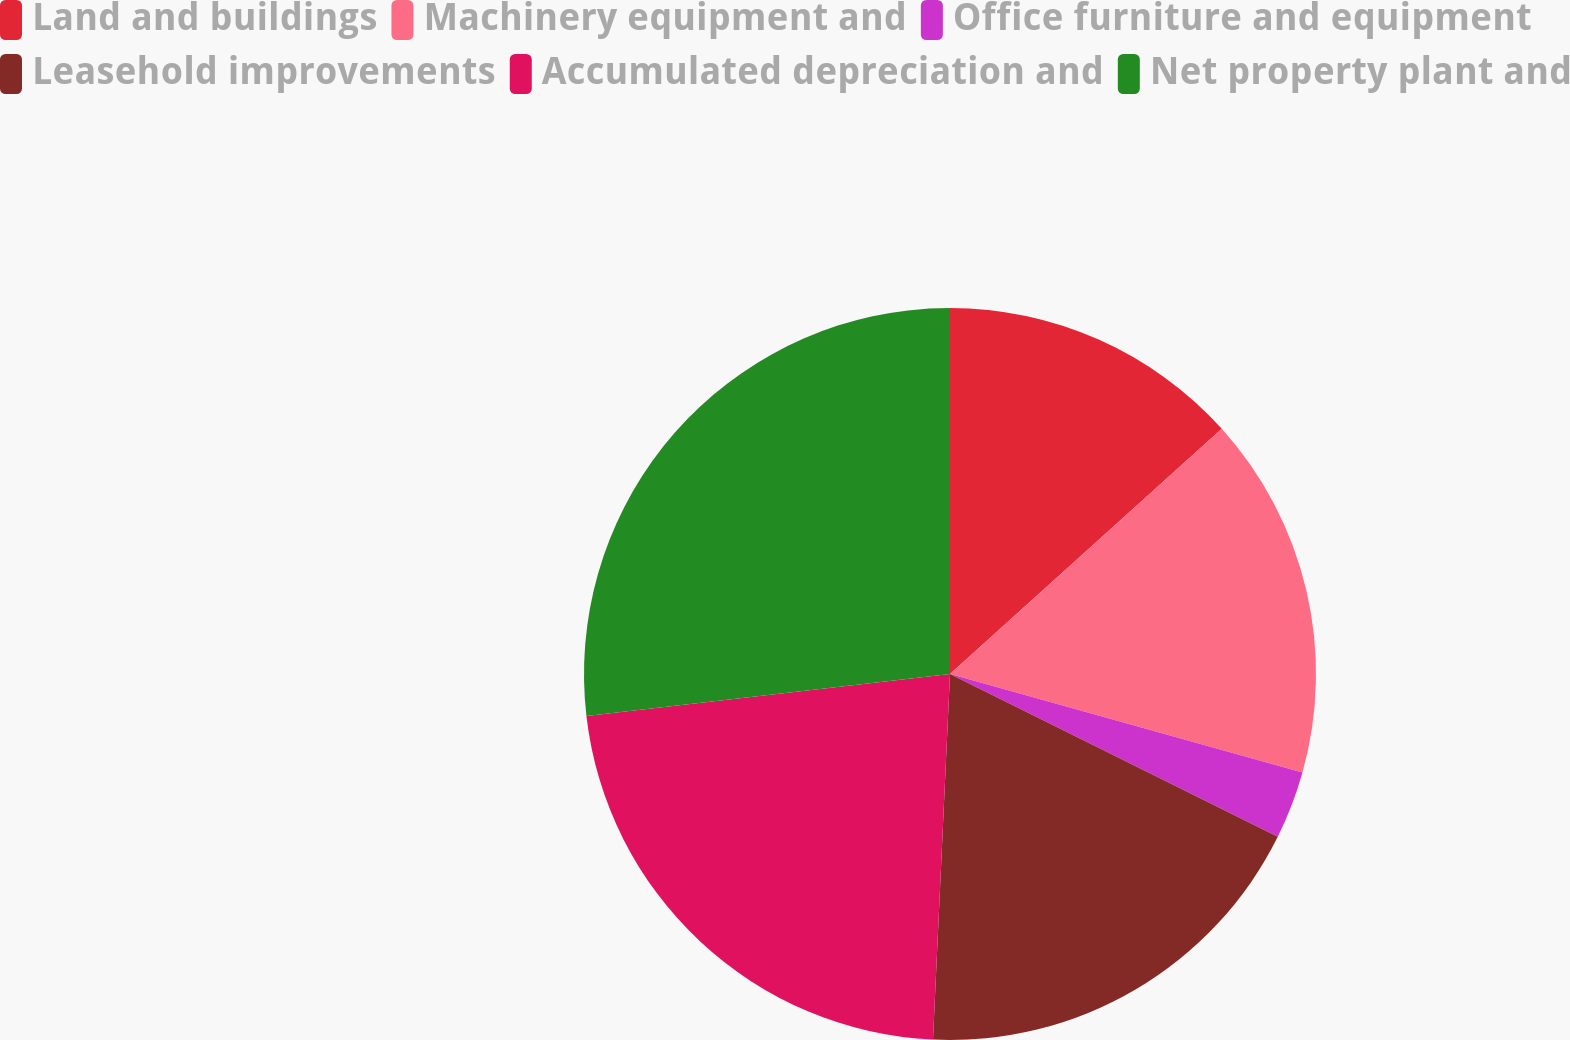Convert chart. <chart><loc_0><loc_0><loc_500><loc_500><pie_chart><fcel>Land and buildings<fcel>Machinery equipment and<fcel>Office furniture and equipment<fcel>Leasehold improvements<fcel>Accumulated depreciation and<fcel>Net property plant and<nl><fcel>13.32%<fcel>16.02%<fcel>3.0%<fcel>18.4%<fcel>22.43%<fcel>26.83%<nl></chart> 